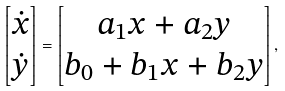Convert formula to latex. <formula><loc_0><loc_0><loc_500><loc_500>\begin{bmatrix} \dot { x } \\ \dot { y } \end{bmatrix} = \begin{bmatrix} a _ { 1 } x + a _ { 2 } y \\ b _ { 0 } + b _ { 1 } x + b _ { 2 } y \end{bmatrix} ,</formula> 